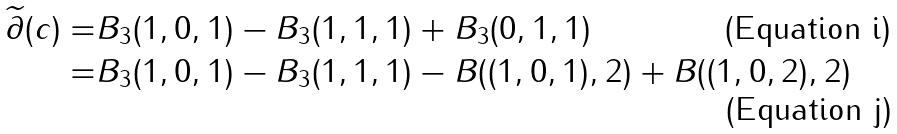<formula> <loc_0><loc_0><loc_500><loc_500>\widetilde { \partial } ( c ) = & B _ { 3 } ( 1 , 0 , 1 ) - B _ { 3 } ( 1 , 1 , 1 ) + B _ { 3 } ( 0 , 1 , 1 ) \\ = & B _ { 3 } ( 1 , 0 , 1 ) - B _ { 3 } ( 1 , 1 , 1 ) - B ( ( 1 , 0 , 1 ) , 2 ) + B ( ( 1 , 0 , 2 ) , 2 )</formula> 